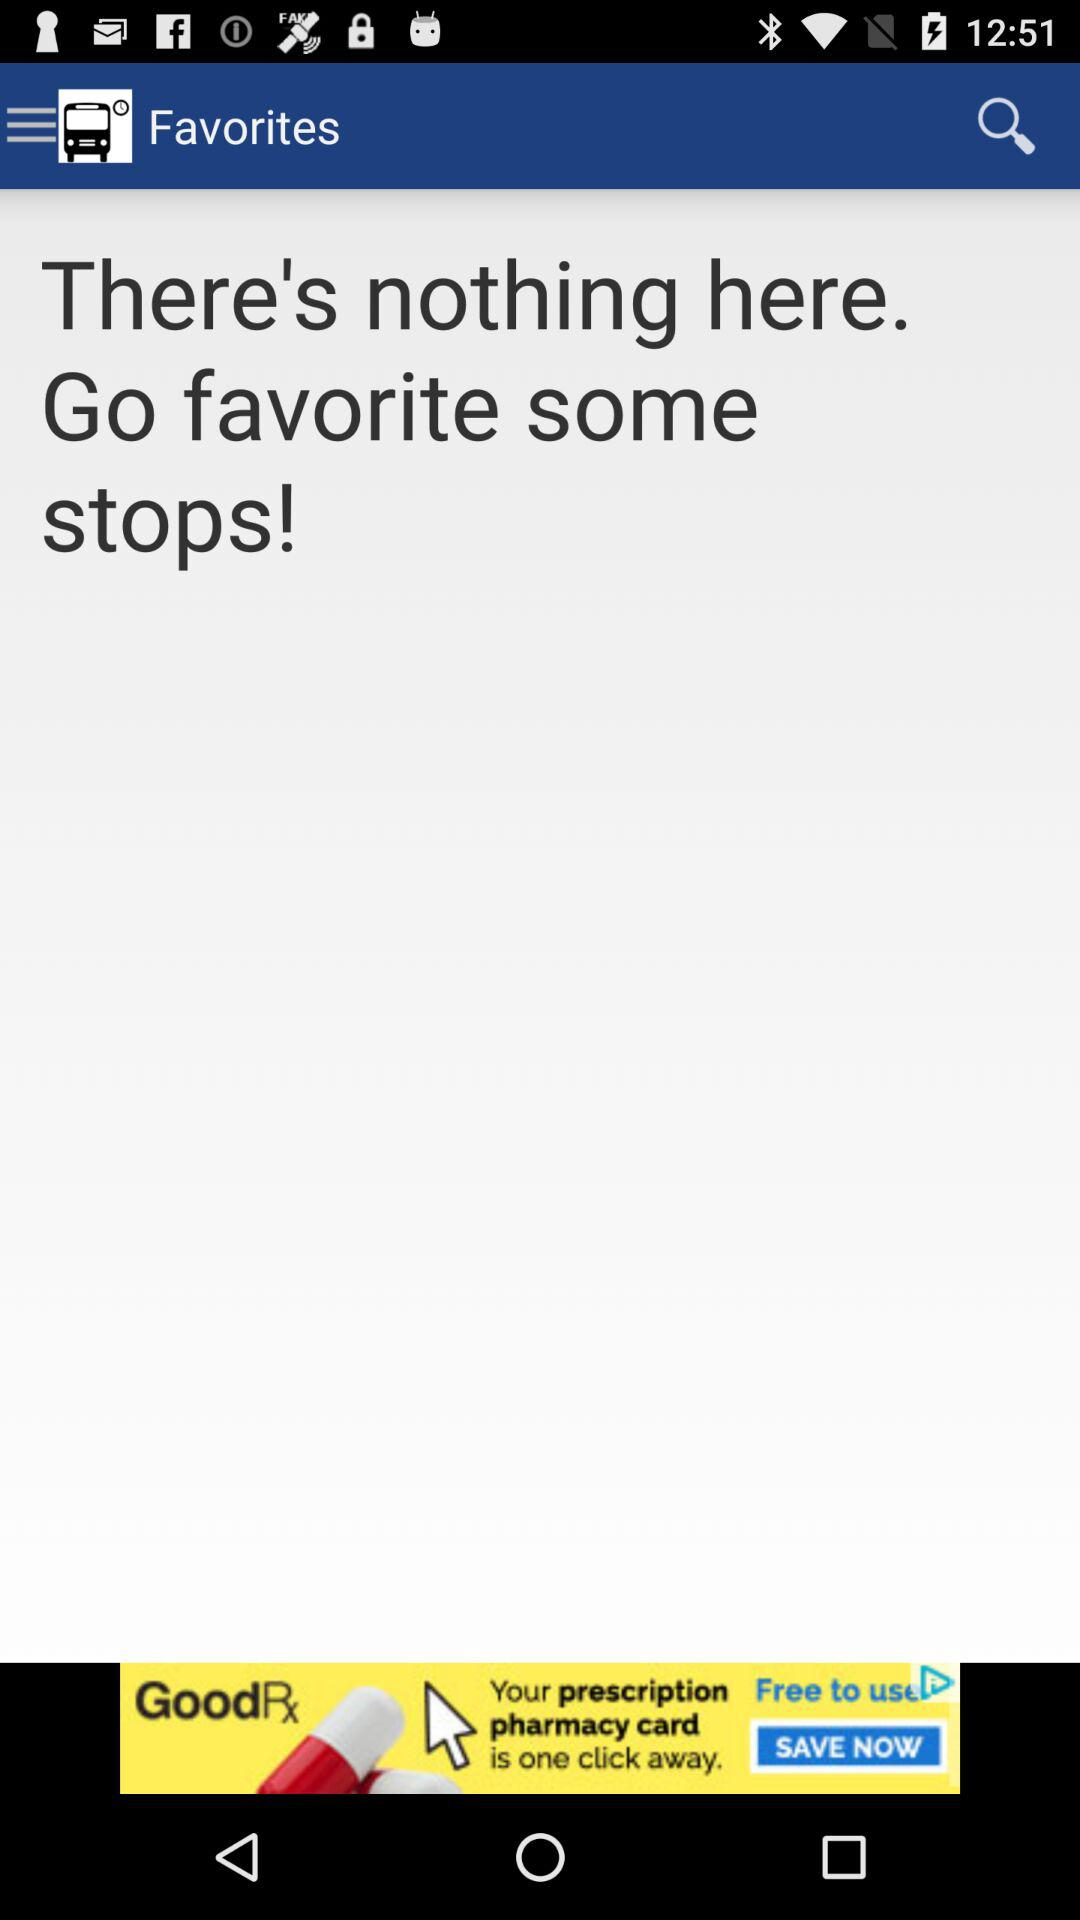How many stops are favorites?
Answer the question using a single word or phrase. 0 